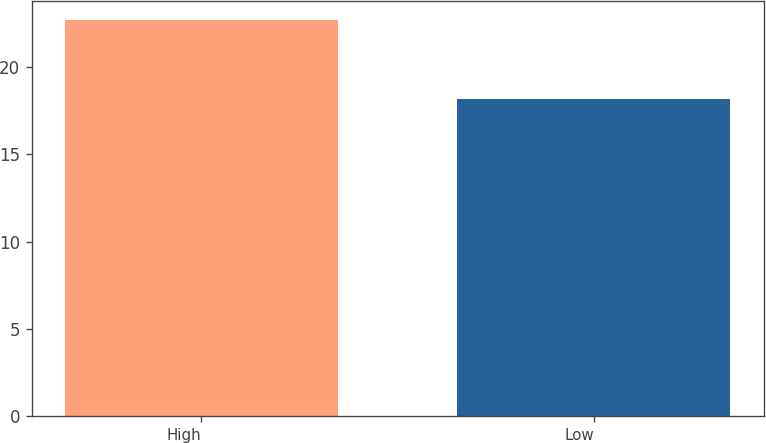<chart> <loc_0><loc_0><loc_500><loc_500><bar_chart><fcel>High<fcel>Low<nl><fcel>22.68<fcel>18.15<nl></chart> 